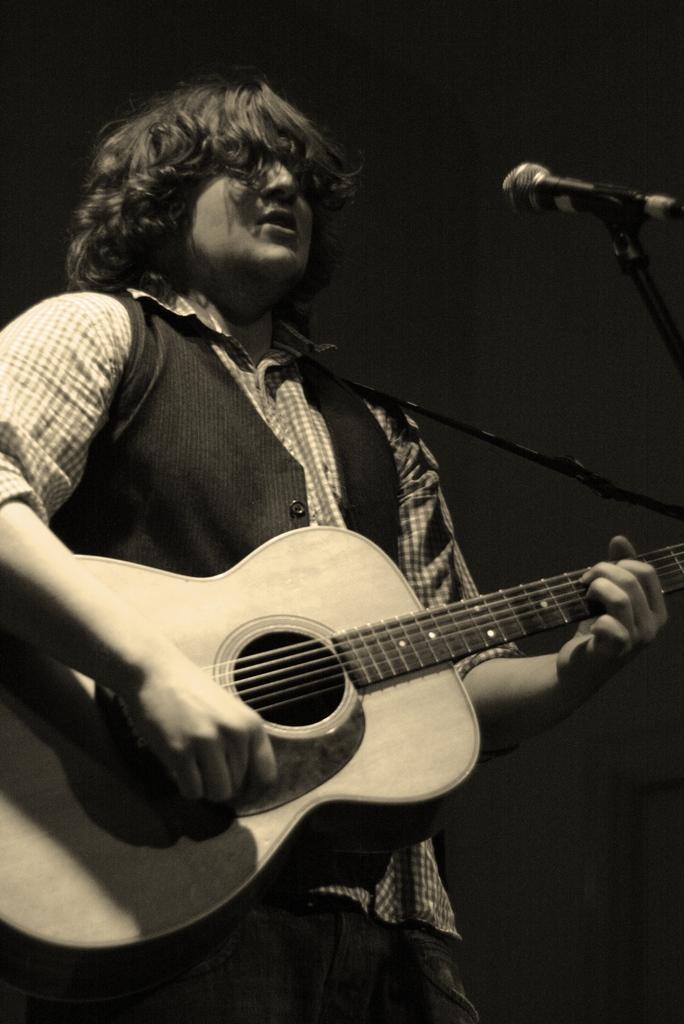Can you describe this image briefly? This picture shows a man playing a guitar and we see a microphone in front of him. 